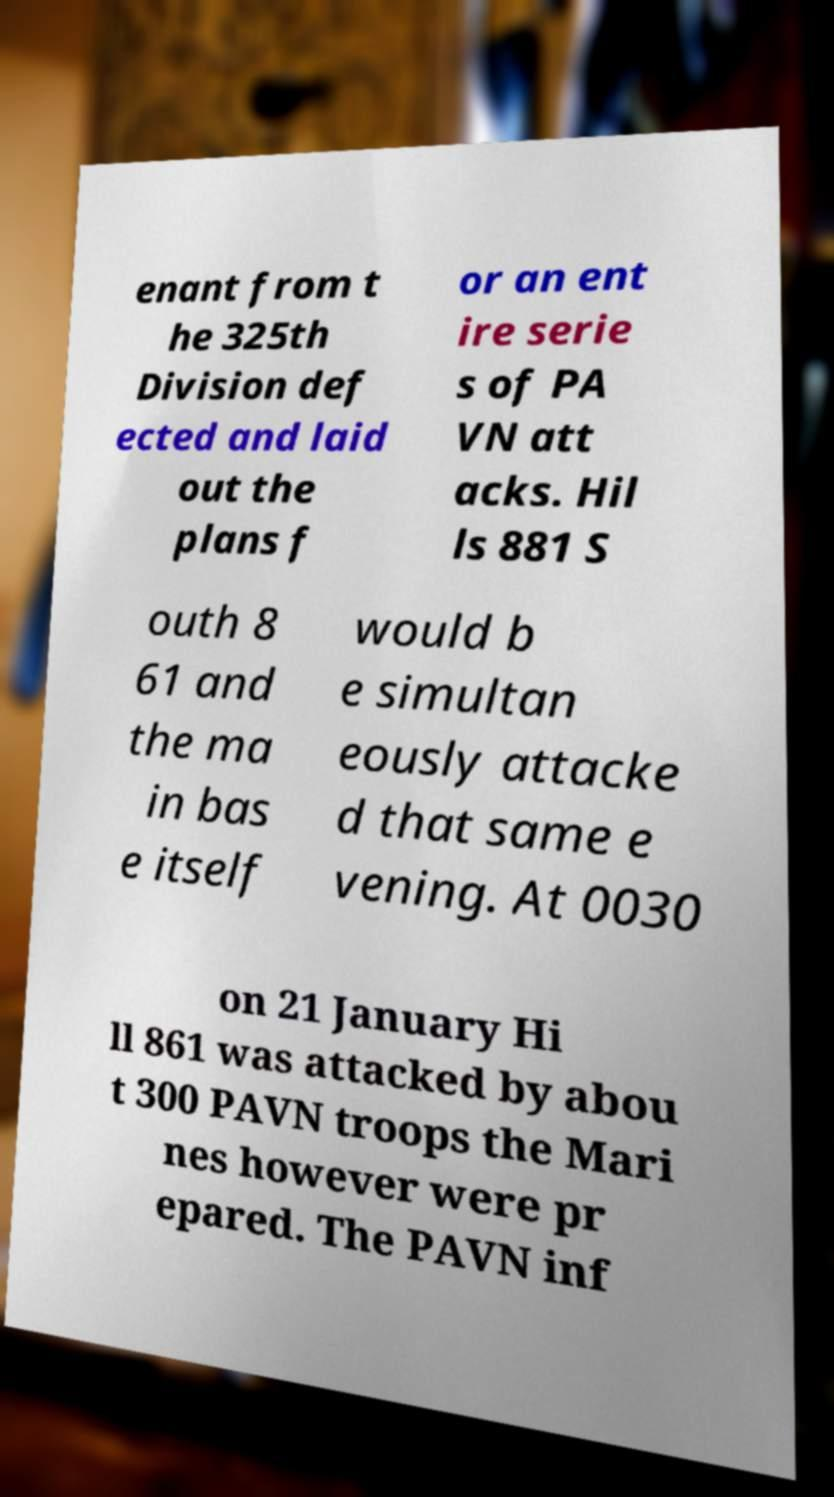Please identify and transcribe the text found in this image. enant from t he 325th Division def ected and laid out the plans f or an ent ire serie s of PA VN att acks. Hil ls 881 S outh 8 61 and the ma in bas e itself would b e simultan eously attacke d that same e vening. At 0030 on 21 January Hi ll 861 was attacked by abou t 300 PAVN troops the Mari nes however were pr epared. The PAVN inf 